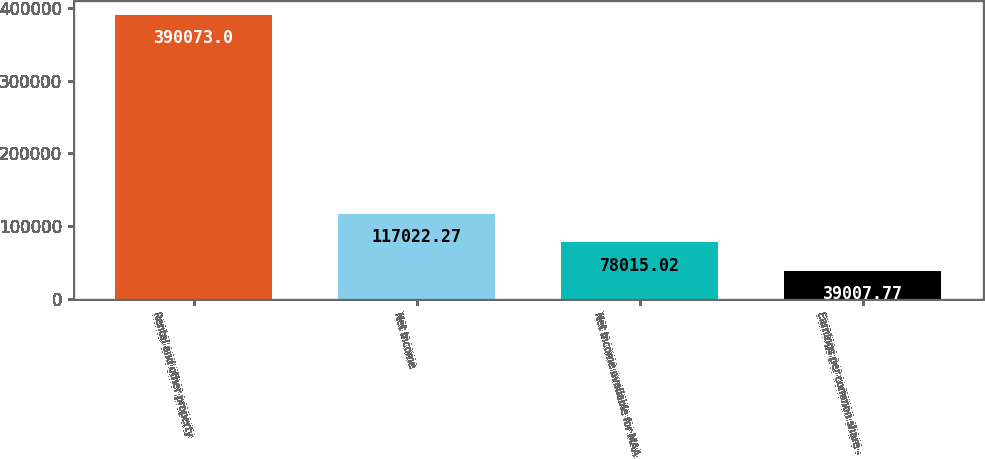Convert chart to OTSL. <chart><loc_0><loc_0><loc_500><loc_500><bar_chart><fcel>Rental and other property<fcel>Net income<fcel>Net income available for MAA<fcel>Earnings per common share -<nl><fcel>390073<fcel>117022<fcel>78015<fcel>39007.8<nl></chart> 